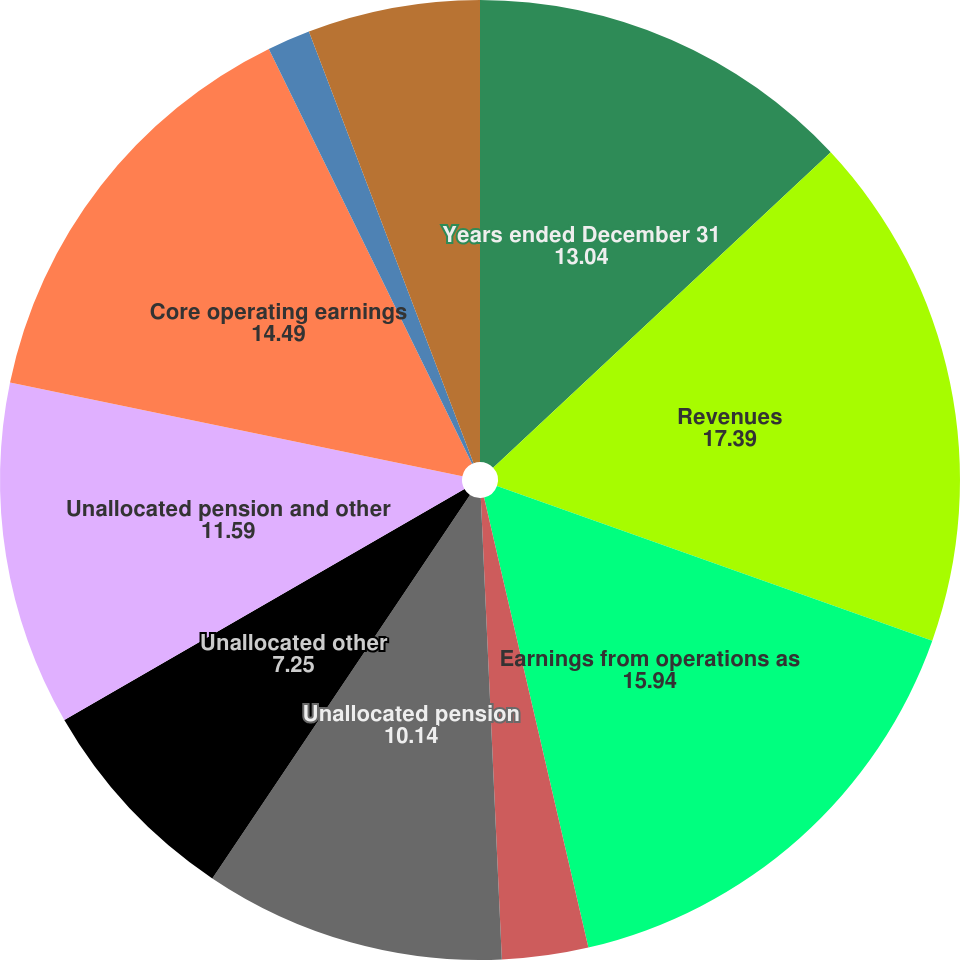<chart> <loc_0><loc_0><loc_500><loc_500><pie_chart><fcel>Years ended December 31<fcel>Revenues<fcel>Earnings from operations as<fcel>Operating margins<fcel>Unallocated pension<fcel>Unallocated other<fcel>Unallocated pension and other<fcel>Core operating earnings<fcel>Core operating margins<fcel>Diluted earnings per share as<nl><fcel>13.04%<fcel>17.39%<fcel>15.94%<fcel>2.9%<fcel>10.14%<fcel>7.25%<fcel>11.59%<fcel>14.49%<fcel>1.45%<fcel>5.8%<nl></chart> 